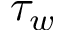Convert formula to latex. <formula><loc_0><loc_0><loc_500><loc_500>\tau _ { w }</formula> 